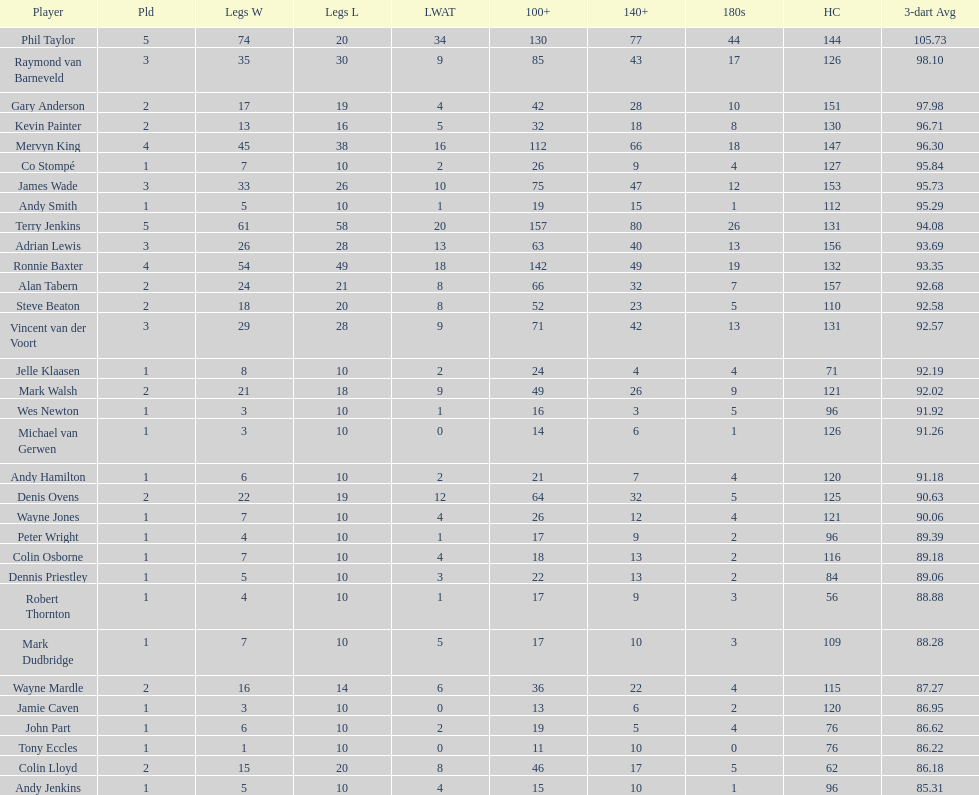Mark walsh's average is above/below 93? Below. 